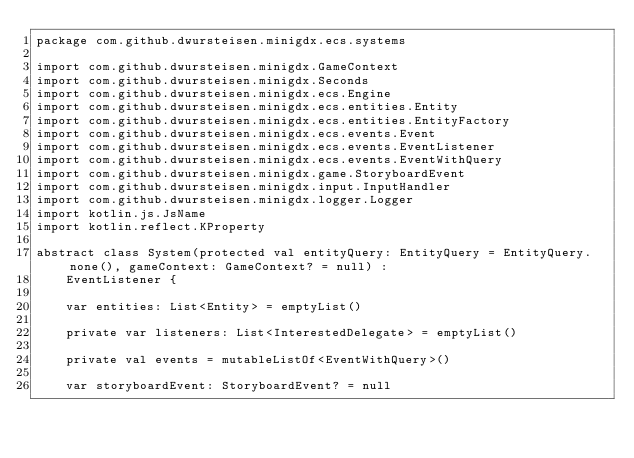Convert code to text. <code><loc_0><loc_0><loc_500><loc_500><_Kotlin_>package com.github.dwursteisen.minigdx.ecs.systems

import com.github.dwursteisen.minigdx.GameContext
import com.github.dwursteisen.minigdx.Seconds
import com.github.dwursteisen.minigdx.ecs.Engine
import com.github.dwursteisen.minigdx.ecs.entities.Entity
import com.github.dwursteisen.minigdx.ecs.entities.EntityFactory
import com.github.dwursteisen.minigdx.ecs.events.Event
import com.github.dwursteisen.minigdx.ecs.events.EventListener
import com.github.dwursteisen.minigdx.ecs.events.EventWithQuery
import com.github.dwursteisen.minigdx.game.StoryboardEvent
import com.github.dwursteisen.minigdx.input.InputHandler
import com.github.dwursteisen.minigdx.logger.Logger
import kotlin.js.JsName
import kotlin.reflect.KProperty

abstract class System(protected val entityQuery: EntityQuery = EntityQuery.none(), gameContext: GameContext? = null) :
    EventListener {

    var entities: List<Entity> = emptyList()

    private var listeners: List<InterestedDelegate> = emptyList()

    private val events = mutableListOf<EventWithQuery>()

    var storyboardEvent: StoryboardEvent? = null</code> 